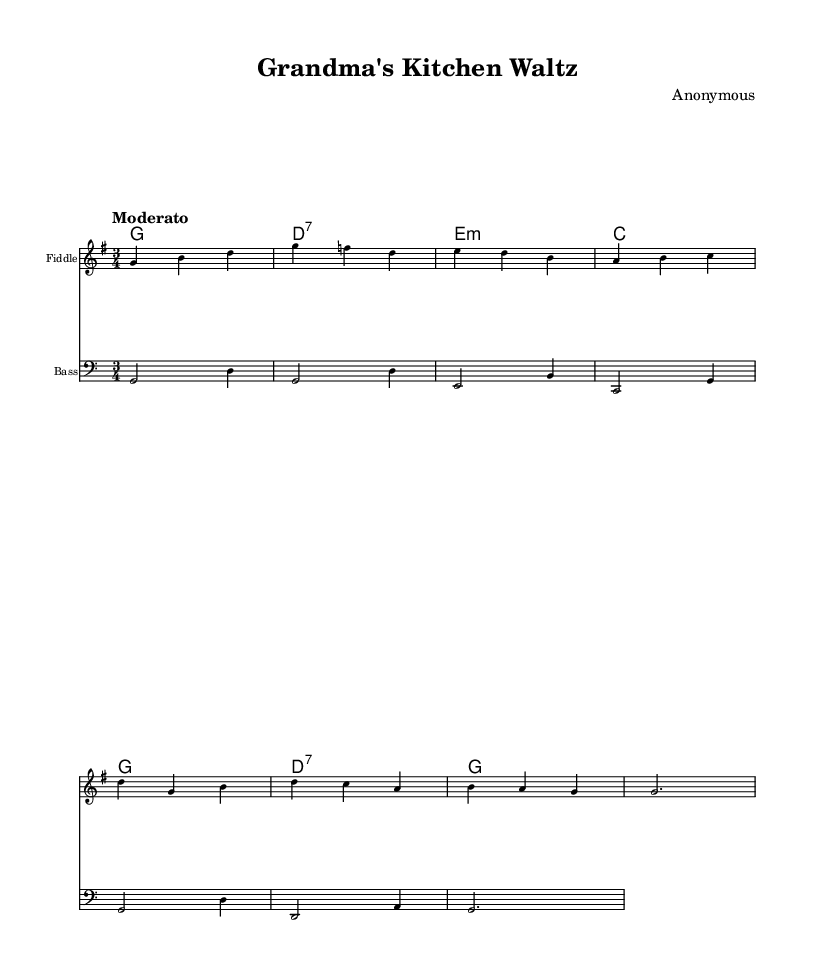What is the key signature of this music? The key signature is G major, which has one sharp (F#). This can be identified by looking at the key signature indicated at the beginning of the staff, which has a sharp sign on the F line.
Answer: G major What is the time signature of this piece? The time signature is 3/4, as seen at the beginning of the staff. The upper number indicates there are three beats in a measure, and the lower number indicates that a quarter note gets one beat.
Answer: 3/4 What is the tempo marking of this music? The tempo marking is "Moderato," which typically indicates a moderate speed for the piece. It is found right after the time signature at the beginning of the score.
Answer: Moderato How many measures are in the melody section? There are eight measures in the melody section. This can be counted by looking at the melody staff and noting the bar lines that divide the measures.
Answer: Eight What is the first note of the melody? The first note of the melody is G. This is determined by reviewing the first note on the staff where the melody is written, which appears at the beginning.
Answer: G Which instrument is indicated for the melody part? The instrument indicated for the melody part is the Fiddle. This is specified at the top of the staff where the instrument name is mentioned.
Answer: Fiddle What type of chord is the second chord in the harmonies? The second chord is a D7 chord, identified by the notation that specifies it as a dominant seventh chord (notated as d2.:7). It shows that it includes the notes D, F#, A, and C.
Answer: D7 